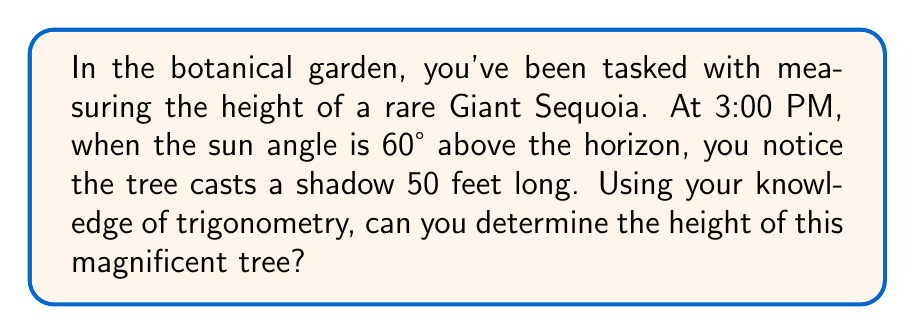Can you solve this math problem? Let's approach this step-by-step:

1) First, we need to visualize the problem. The tree, its shadow, and the sun's rays form a right triangle.

2) We know:
   - The angle of elevation of the sun is 60°
   - The length of the shadow is 50 feet

3) Let's define our variables:
   - Let $h$ be the height of the tree
   - The shadow length is 50 feet

4) In this right triangle:
   - The shadow length is the adjacent side to the 60° angle
   - The tree height is the opposite side to the 60° angle

5) We can use the tangent ratio:

   $$\tan \theta = \frac{\text{opposite}}{\text{adjacent}}$$

6) Plugging in our values:

   $$\tan 60° = \frac{h}{50}$$

7) We know that $\tan 60° = \sqrt{3}$, so:

   $$\sqrt{3} = \frac{h}{50}$$

8) Solve for $h$:

   $$h = 50\sqrt{3}$$

9) To get a decimal approximation:

   $$h \approx 50 \cdot 1.732 \approx 86.6 \text{ feet}$$

Thus, the Giant Sequoia is approximately 86.6 feet tall.
Answer: $50\sqrt{3}$ feet or approximately 86.6 feet 